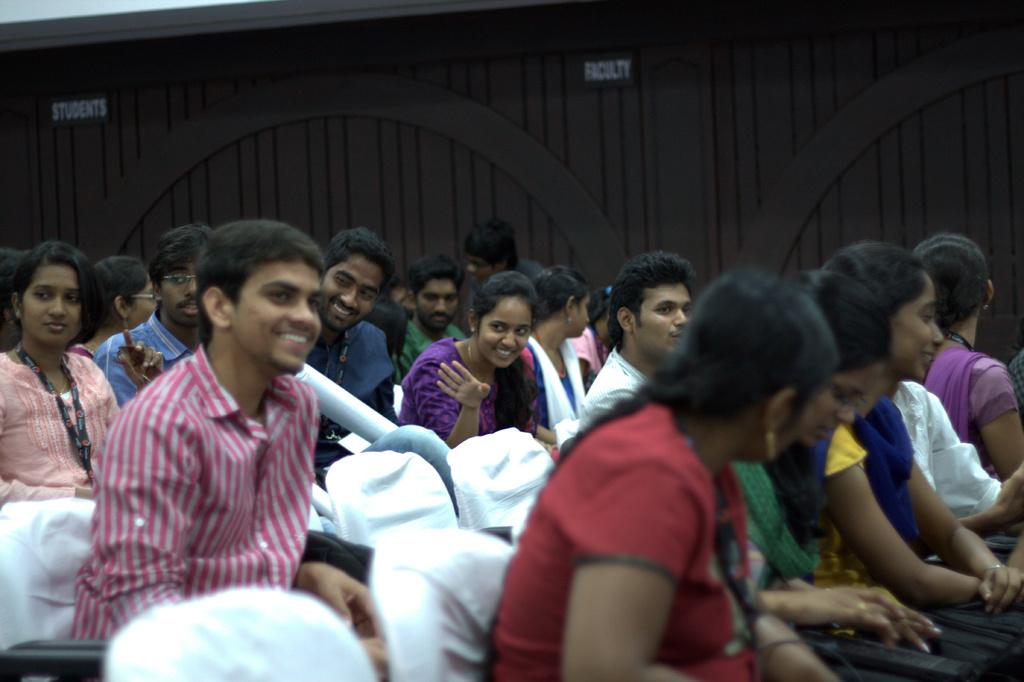What is happening in the image? There is a group of people in the image, and they are sitting on chairs. What can be seen in the background of the image? There are boards visible in the background of the image. Are there any cherries being lifted by a tooth in the image? No, there are no cherries or teeth involved in any activity in the image. 